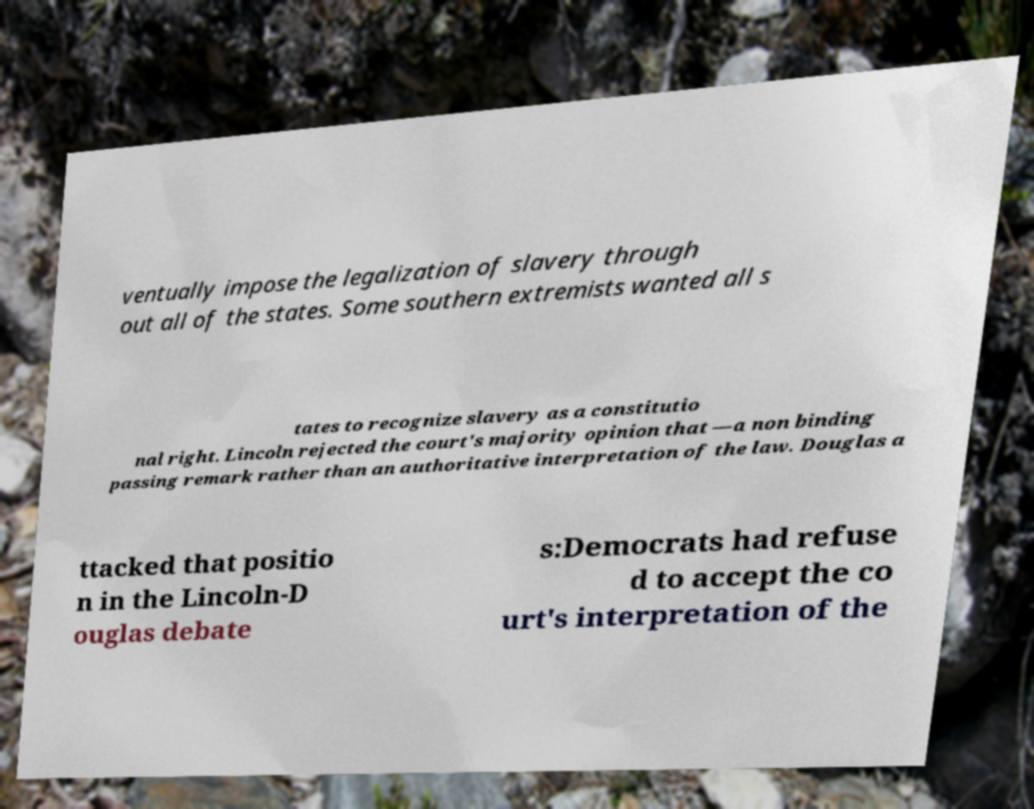I need the written content from this picture converted into text. Can you do that? ventually impose the legalization of slavery through out all of the states. Some southern extremists wanted all s tates to recognize slavery as a constitutio nal right. Lincoln rejected the court's majority opinion that —a non binding passing remark rather than an authoritative interpretation of the law. Douglas a ttacked that positio n in the Lincoln-D ouglas debate s:Democrats had refuse d to accept the co urt's interpretation of the 